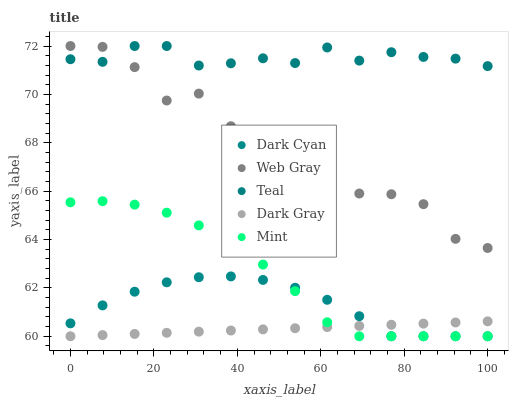Does Dark Gray have the minimum area under the curve?
Answer yes or no. Yes. Does Teal have the maximum area under the curve?
Answer yes or no. Yes. Does Web Gray have the minimum area under the curve?
Answer yes or no. No. Does Web Gray have the maximum area under the curve?
Answer yes or no. No. Is Dark Gray the smoothest?
Answer yes or no. Yes. Is Web Gray the roughest?
Answer yes or no. Yes. Is Web Gray the smoothest?
Answer yes or no. No. Is Dark Gray the roughest?
Answer yes or no. No. Does Dark Cyan have the lowest value?
Answer yes or no. Yes. Does Web Gray have the lowest value?
Answer yes or no. No. Does Teal have the highest value?
Answer yes or no. Yes. Does Dark Gray have the highest value?
Answer yes or no. No. Is Dark Gray less than Web Gray?
Answer yes or no. Yes. Is Teal greater than Mint?
Answer yes or no. Yes. Does Teal intersect Web Gray?
Answer yes or no. Yes. Is Teal less than Web Gray?
Answer yes or no. No. Is Teal greater than Web Gray?
Answer yes or no. No. Does Dark Gray intersect Web Gray?
Answer yes or no. No. 